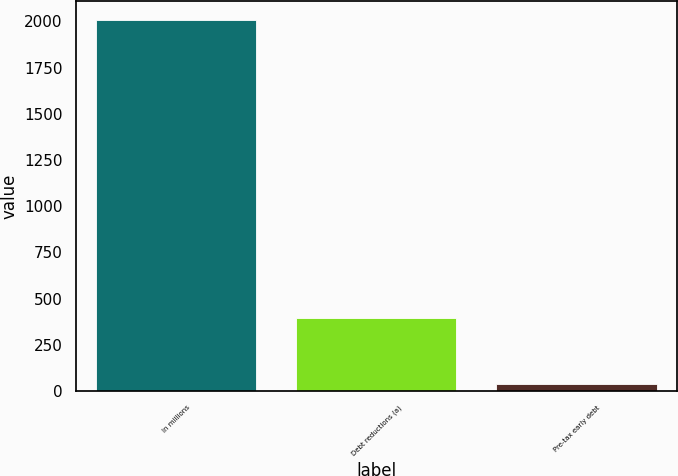<chart> <loc_0><loc_0><loc_500><loc_500><bar_chart><fcel>In millions<fcel>Debt reductions (a)<fcel>Pre-tax early debt<nl><fcel>2010<fcel>393<fcel>39<nl></chart> 